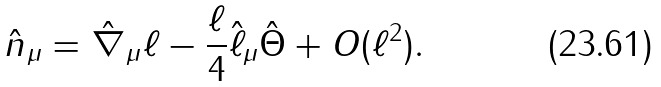<formula> <loc_0><loc_0><loc_500><loc_500>\hat { n } _ { \mu } = \hat { \nabla } _ { \mu } \ell - \frac { \ell } { 4 } \hat { \ell } _ { \mu } \hat { \Theta } + O ( \ell ^ { 2 } ) .</formula> 